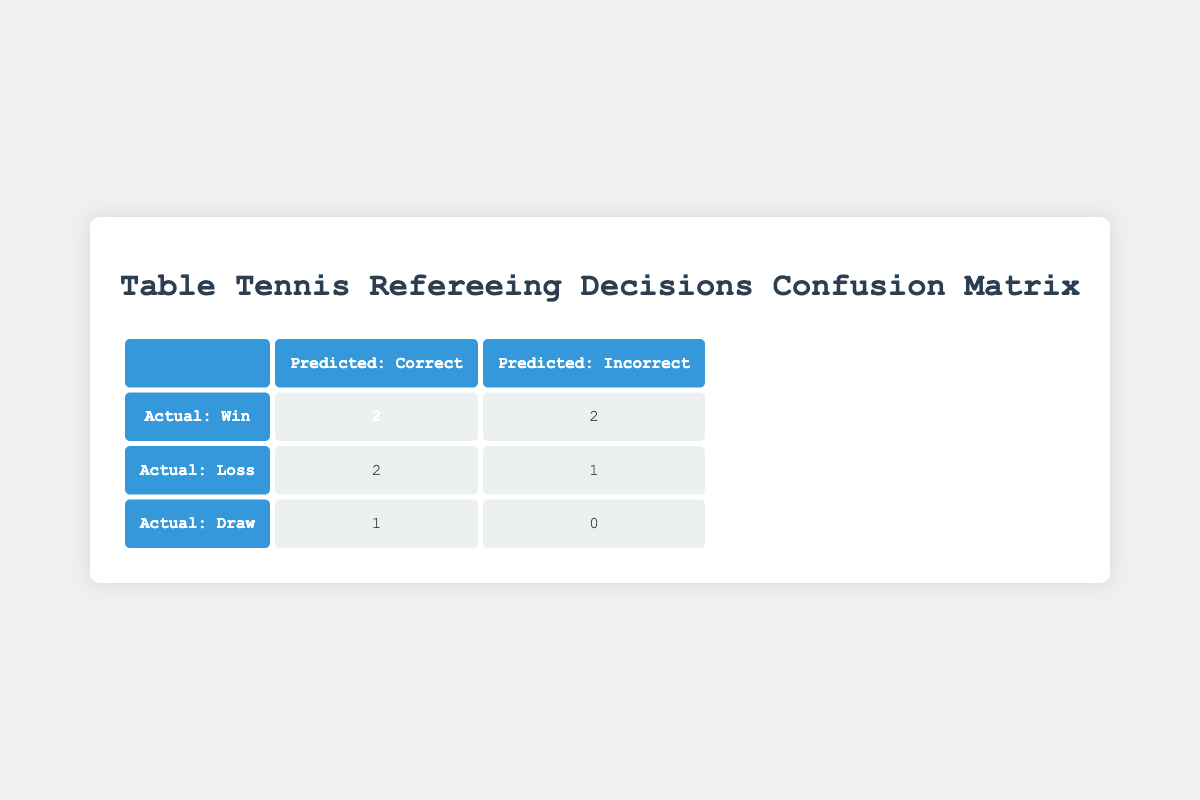What is the total number of matches where the refereeing decision was correct? From the table, we can see the number of matches with correct decisions by looking at the cells under "Predicted: Correct." The values are 2 for "Actual: Win", 2 for "Actual: Loss," and 1 for "Actual: Draw." Summing them up gives 2 + 2 + 1 = 5.
Answer: 5 How many matches resulted in a win where the decision was incorrect? Referring to the table, we find that under "Actual: Win" and "Predicted: Incorrect," there are 2 occurrences. Therefore, the answer is straightforward as it is directly listed in the table.
Answer: 2 Is it true that there are more matches with draws than with incorrect refereeing decisions resulting in losses? For draws, the table shows 1 match under "Actual: Draw." For losses with incorrect decisions, the table shows 1 under "Actual: Loss" and "Predicted: Incorrect." Thus, we see that 1 is equal to 1, so the statement is false.
Answer: No What percentage of the total matches ended in wins, regardless of refereeing decision? There are a total of 8 matches in the table. Out of these, 4 matches resulted in wins (2 correct + 2 incorrect). The percentage is calculated by (4 wins / 8 total matches) * 100 = 50%.
Answer: 50% If we consider only the matches with correct decisions, what is the ratio of wins to losses? Looking at the "Correct" predictions, we see 2 wins (from "Actual: Win") and 2 losses (from "Actual: Loss"). The ratio of wins to losses is 2:2, which simplifies to 1:1.
Answer: 1:1 How many matches had a decision that was marked incorrect, but resulted in a win for the team? The table indicates that there are 2 instances where the outcome was a win and the refereeing decision was incorrect (under "Actual: Win" and "Predicted: Incorrect").
Answer: 2 What is the total count of matches where the outcome was a loss and the decision was correct? By looking under "Actual: Loss" and "Predicted: Correct," the table lists 2 matches. This value provides a direct answer with no further calculation needed.
Answer: 2 Are there any matches that ended in a draw with an incorrect decision? The table shows that under "Actual: Draw," there is 1 match, and it falls under "Predicted: Correct." Since there are no entries under "Predicted: Incorrect" for draws, the answer is no.
Answer: No 